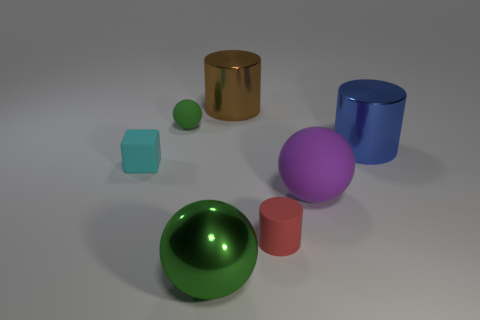Add 2 tiny gray matte cylinders. How many objects exist? 9 Subtract all cylinders. How many objects are left? 4 Add 5 tiny spheres. How many tiny spheres are left? 6 Add 2 cyan objects. How many cyan objects exist? 3 Subtract 0 red cubes. How many objects are left? 7 Subtract all small purple matte cylinders. Subtract all large purple matte objects. How many objects are left? 6 